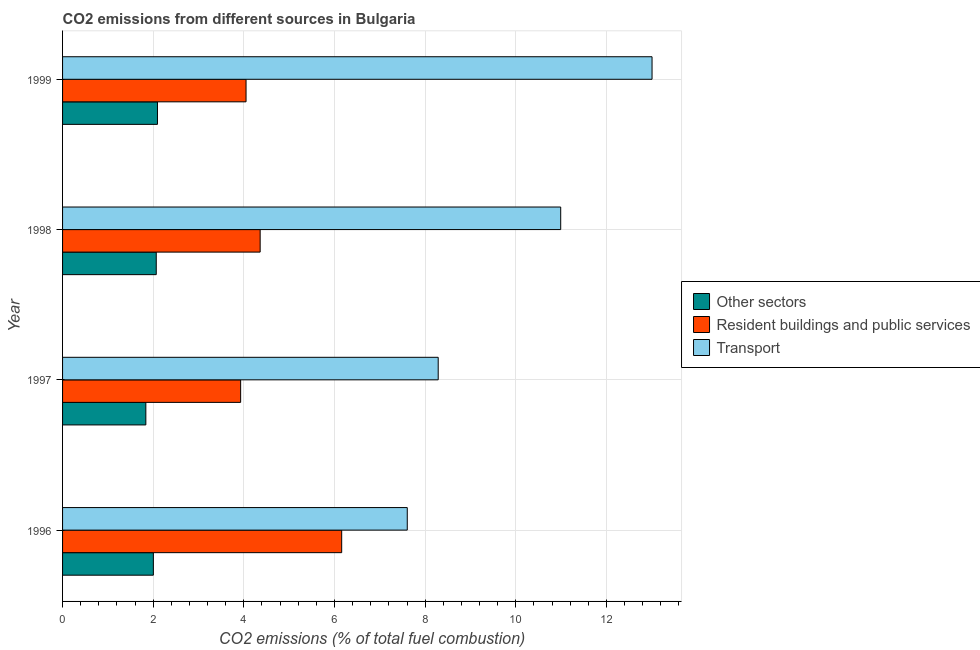How many different coloured bars are there?
Your response must be concise. 3. How many groups of bars are there?
Your answer should be compact. 4. How many bars are there on the 1st tick from the bottom?
Offer a very short reply. 3. In how many cases, is the number of bars for a given year not equal to the number of legend labels?
Offer a terse response. 0. What is the percentage of co2 emissions from transport in 1999?
Keep it short and to the point. 13.01. Across all years, what is the maximum percentage of co2 emissions from transport?
Offer a terse response. 13.01. Across all years, what is the minimum percentage of co2 emissions from resident buildings and public services?
Give a very brief answer. 3.93. In which year was the percentage of co2 emissions from resident buildings and public services maximum?
Your answer should be compact. 1996. What is the total percentage of co2 emissions from resident buildings and public services in the graph?
Your answer should be very brief. 18.5. What is the difference between the percentage of co2 emissions from other sectors in 1996 and that in 1999?
Provide a succinct answer. -0.09. What is the difference between the percentage of co2 emissions from other sectors in 1997 and the percentage of co2 emissions from transport in 1998?
Provide a short and direct response. -9.15. What is the average percentage of co2 emissions from transport per year?
Make the answer very short. 9.97. In the year 1999, what is the difference between the percentage of co2 emissions from other sectors and percentage of co2 emissions from transport?
Provide a short and direct response. -10.91. What is the ratio of the percentage of co2 emissions from resident buildings and public services in 1997 to that in 1998?
Give a very brief answer. 0.9. Is the difference between the percentage of co2 emissions from resident buildings and public services in 1996 and 1997 greater than the difference between the percentage of co2 emissions from other sectors in 1996 and 1997?
Provide a short and direct response. Yes. What is the difference between the highest and the second highest percentage of co2 emissions from transport?
Keep it short and to the point. 2.02. What is the difference between the highest and the lowest percentage of co2 emissions from other sectors?
Your answer should be compact. 0.26. What does the 3rd bar from the top in 1997 represents?
Your response must be concise. Other sectors. What does the 3rd bar from the bottom in 1997 represents?
Offer a very short reply. Transport. Is it the case that in every year, the sum of the percentage of co2 emissions from other sectors and percentage of co2 emissions from resident buildings and public services is greater than the percentage of co2 emissions from transport?
Provide a succinct answer. No. How many bars are there?
Your answer should be very brief. 12. Are all the bars in the graph horizontal?
Your answer should be very brief. Yes. How many years are there in the graph?
Keep it short and to the point. 4. What is the difference between two consecutive major ticks on the X-axis?
Offer a terse response. 2. Does the graph contain grids?
Your answer should be very brief. Yes. What is the title of the graph?
Provide a succinct answer. CO2 emissions from different sources in Bulgaria. What is the label or title of the X-axis?
Provide a succinct answer. CO2 emissions (% of total fuel combustion). What is the CO2 emissions (% of total fuel combustion) of Other sectors in 1996?
Make the answer very short. 2. What is the CO2 emissions (% of total fuel combustion) in Resident buildings and public services in 1996?
Your answer should be very brief. 6.16. What is the CO2 emissions (% of total fuel combustion) in Transport in 1996?
Give a very brief answer. 7.61. What is the CO2 emissions (% of total fuel combustion) in Other sectors in 1997?
Your response must be concise. 1.84. What is the CO2 emissions (% of total fuel combustion) in Resident buildings and public services in 1997?
Make the answer very short. 3.93. What is the CO2 emissions (% of total fuel combustion) of Transport in 1997?
Keep it short and to the point. 8.29. What is the CO2 emissions (% of total fuel combustion) of Other sectors in 1998?
Provide a short and direct response. 2.07. What is the CO2 emissions (% of total fuel combustion) of Resident buildings and public services in 1998?
Provide a succinct answer. 4.36. What is the CO2 emissions (% of total fuel combustion) in Transport in 1998?
Your response must be concise. 10.99. What is the CO2 emissions (% of total fuel combustion) of Other sectors in 1999?
Your answer should be compact. 2.09. What is the CO2 emissions (% of total fuel combustion) of Resident buildings and public services in 1999?
Keep it short and to the point. 4.05. What is the CO2 emissions (% of total fuel combustion) in Transport in 1999?
Provide a short and direct response. 13.01. Across all years, what is the maximum CO2 emissions (% of total fuel combustion) of Other sectors?
Make the answer very short. 2.09. Across all years, what is the maximum CO2 emissions (% of total fuel combustion) of Resident buildings and public services?
Keep it short and to the point. 6.16. Across all years, what is the maximum CO2 emissions (% of total fuel combustion) in Transport?
Offer a terse response. 13.01. Across all years, what is the minimum CO2 emissions (% of total fuel combustion) of Other sectors?
Your answer should be compact. 1.84. Across all years, what is the minimum CO2 emissions (% of total fuel combustion) of Resident buildings and public services?
Your answer should be very brief. 3.93. Across all years, what is the minimum CO2 emissions (% of total fuel combustion) of Transport?
Provide a short and direct response. 7.61. What is the total CO2 emissions (% of total fuel combustion) in Other sectors in the graph?
Make the answer very short. 8. What is the total CO2 emissions (% of total fuel combustion) in Resident buildings and public services in the graph?
Provide a succinct answer. 18.5. What is the total CO2 emissions (% of total fuel combustion) in Transport in the graph?
Offer a terse response. 39.89. What is the difference between the CO2 emissions (% of total fuel combustion) of Other sectors in 1996 and that in 1997?
Offer a very short reply. 0.17. What is the difference between the CO2 emissions (% of total fuel combustion) in Resident buildings and public services in 1996 and that in 1997?
Your answer should be compact. 2.23. What is the difference between the CO2 emissions (% of total fuel combustion) in Transport in 1996 and that in 1997?
Your answer should be compact. -0.68. What is the difference between the CO2 emissions (% of total fuel combustion) in Other sectors in 1996 and that in 1998?
Your response must be concise. -0.06. What is the difference between the CO2 emissions (% of total fuel combustion) of Resident buildings and public services in 1996 and that in 1998?
Keep it short and to the point. 1.8. What is the difference between the CO2 emissions (% of total fuel combustion) in Transport in 1996 and that in 1998?
Give a very brief answer. -3.39. What is the difference between the CO2 emissions (% of total fuel combustion) of Other sectors in 1996 and that in 1999?
Provide a short and direct response. -0.09. What is the difference between the CO2 emissions (% of total fuel combustion) in Resident buildings and public services in 1996 and that in 1999?
Your answer should be very brief. 2.11. What is the difference between the CO2 emissions (% of total fuel combustion) of Transport in 1996 and that in 1999?
Your answer should be compact. -5.4. What is the difference between the CO2 emissions (% of total fuel combustion) of Other sectors in 1997 and that in 1998?
Ensure brevity in your answer.  -0.23. What is the difference between the CO2 emissions (% of total fuel combustion) of Resident buildings and public services in 1997 and that in 1998?
Provide a short and direct response. -0.43. What is the difference between the CO2 emissions (% of total fuel combustion) of Transport in 1997 and that in 1998?
Give a very brief answer. -2.7. What is the difference between the CO2 emissions (% of total fuel combustion) of Other sectors in 1997 and that in 1999?
Your answer should be compact. -0.26. What is the difference between the CO2 emissions (% of total fuel combustion) of Resident buildings and public services in 1997 and that in 1999?
Give a very brief answer. -0.12. What is the difference between the CO2 emissions (% of total fuel combustion) of Transport in 1997 and that in 1999?
Ensure brevity in your answer.  -4.72. What is the difference between the CO2 emissions (% of total fuel combustion) of Other sectors in 1998 and that in 1999?
Offer a terse response. -0.03. What is the difference between the CO2 emissions (% of total fuel combustion) of Resident buildings and public services in 1998 and that in 1999?
Give a very brief answer. 0.31. What is the difference between the CO2 emissions (% of total fuel combustion) of Transport in 1998 and that in 1999?
Give a very brief answer. -2.02. What is the difference between the CO2 emissions (% of total fuel combustion) of Other sectors in 1996 and the CO2 emissions (% of total fuel combustion) of Resident buildings and public services in 1997?
Offer a terse response. -1.93. What is the difference between the CO2 emissions (% of total fuel combustion) of Other sectors in 1996 and the CO2 emissions (% of total fuel combustion) of Transport in 1997?
Your answer should be compact. -6.28. What is the difference between the CO2 emissions (% of total fuel combustion) of Resident buildings and public services in 1996 and the CO2 emissions (% of total fuel combustion) of Transport in 1997?
Give a very brief answer. -2.13. What is the difference between the CO2 emissions (% of total fuel combustion) in Other sectors in 1996 and the CO2 emissions (% of total fuel combustion) in Resident buildings and public services in 1998?
Provide a succinct answer. -2.36. What is the difference between the CO2 emissions (% of total fuel combustion) of Other sectors in 1996 and the CO2 emissions (% of total fuel combustion) of Transport in 1998?
Your answer should be very brief. -8.99. What is the difference between the CO2 emissions (% of total fuel combustion) of Resident buildings and public services in 1996 and the CO2 emissions (% of total fuel combustion) of Transport in 1998?
Ensure brevity in your answer.  -4.83. What is the difference between the CO2 emissions (% of total fuel combustion) of Other sectors in 1996 and the CO2 emissions (% of total fuel combustion) of Resident buildings and public services in 1999?
Provide a short and direct response. -2.05. What is the difference between the CO2 emissions (% of total fuel combustion) in Other sectors in 1996 and the CO2 emissions (% of total fuel combustion) in Transport in 1999?
Offer a terse response. -11. What is the difference between the CO2 emissions (% of total fuel combustion) in Resident buildings and public services in 1996 and the CO2 emissions (% of total fuel combustion) in Transport in 1999?
Your answer should be very brief. -6.85. What is the difference between the CO2 emissions (% of total fuel combustion) in Other sectors in 1997 and the CO2 emissions (% of total fuel combustion) in Resident buildings and public services in 1998?
Give a very brief answer. -2.52. What is the difference between the CO2 emissions (% of total fuel combustion) of Other sectors in 1997 and the CO2 emissions (% of total fuel combustion) of Transport in 1998?
Ensure brevity in your answer.  -9.15. What is the difference between the CO2 emissions (% of total fuel combustion) in Resident buildings and public services in 1997 and the CO2 emissions (% of total fuel combustion) in Transport in 1998?
Your answer should be very brief. -7.06. What is the difference between the CO2 emissions (% of total fuel combustion) in Other sectors in 1997 and the CO2 emissions (% of total fuel combustion) in Resident buildings and public services in 1999?
Your response must be concise. -2.21. What is the difference between the CO2 emissions (% of total fuel combustion) in Other sectors in 1997 and the CO2 emissions (% of total fuel combustion) in Transport in 1999?
Offer a terse response. -11.17. What is the difference between the CO2 emissions (% of total fuel combustion) in Resident buildings and public services in 1997 and the CO2 emissions (% of total fuel combustion) in Transport in 1999?
Ensure brevity in your answer.  -9.08. What is the difference between the CO2 emissions (% of total fuel combustion) in Other sectors in 1998 and the CO2 emissions (% of total fuel combustion) in Resident buildings and public services in 1999?
Provide a short and direct response. -1.98. What is the difference between the CO2 emissions (% of total fuel combustion) of Other sectors in 1998 and the CO2 emissions (% of total fuel combustion) of Transport in 1999?
Your answer should be very brief. -10.94. What is the difference between the CO2 emissions (% of total fuel combustion) of Resident buildings and public services in 1998 and the CO2 emissions (% of total fuel combustion) of Transport in 1999?
Provide a succinct answer. -8.65. What is the average CO2 emissions (% of total fuel combustion) of Other sectors per year?
Give a very brief answer. 2. What is the average CO2 emissions (% of total fuel combustion) in Resident buildings and public services per year?
Provide a succinct answer. 4.62. What is the average CO2 emissions (% of total fuel combustion) in Transport per year?
Make the answer very short. 9.97. In the year 1996, what is the difference between the CO2 emissions (% of total fuel combustion) of Other sectors and CO2 emissions (% of total fuel combustion) of Resident buildings and public services?
Give a very brief answer. -4.16. In the year 1996, what is the difference between the CO2 emissions (% of total fuel combustion) of Other sectors and CO2 emissions (% of total fuel combustion) of Transport?
Offer a very short reply. -5.6. In the year 1996, what is the difference between the CO2 emissions (% of total fuel combustion) in Resident buildings and public services and CO2 emissions (% of total fuel combustion) in Transport?
Give a very brief answer. -1.45. In the year 1997, what is the difference between the CO2 emissions (% of total fuel combustion) of Other sectors and CO2 emissions (% of total fuel combustion) of Resident buildings and public services?
Ensure brevity in your answer.  -2.09. In the year 1997, what is the difference between the CO2 emissions (% of total fuel combustion) in Other sectors and CO2 emissions (% of total fuel combustion) in Transport?
Make the answer very short. -6.45. In the year 1997, what is the difference between the CO2 emissions (% of total fuel combustion) of Resident buildings and public services and CO2 emissions (% of total fuel combustion) of Transport?
Give a very brief answer. -4.36. In the year 1998, what is the difference between the CO2 emissions (% of total fuel combustion) of Other sectors and CO2 emissions (% of total fuel combustion) of Resident buildings and public services?
Your answer should be compact. -2.29. In the year 1998, what is the difference between the CO2 emissions (% of total fuel combustion) of Other sectors and CO2 emissions (% of total fuel combustion) of Transport?
Your answer should be very brief. -8.92. In the year 1998, what is the difference between the CO2 emissions (% of total fuel combustion) of Resident buildings and public services and CO2 emissions (% of total fuel combustion) of Transport?
Your answer should be very brief. -6.63. In the year 1999, what is the difference between the CO2 emissions (% of total fuel combustion) in Other sectors and CO2 emissions (% of total fuel combustion) in Resident buildings and public services?
Your answer should be compact. -1.95. In the year 1999, what is the difference between the CO2 emissions (% of total fuel combustion) in Other sectors and CO2 emissions (% of total fuel combustion) in Transport?
Your answer should be compact. -10.91. In the year 1999, what is the difference between the CO2 emissions (% of total fuel combustion) in Resident buildings and public services and CO2 emissions (% of total fuel combustion) in Transport?
Give a very brief answer. -8.96. What is the ratio of the CO2 emissions (% of total fuel combustion) of Other sectors in 1996 to that in 1997?
Your response must be concise. 1.09. What is the ratio of the CO2 emissions (% of total fuel combustion) of Resident buildings and public services in 1996 to that in 1997?
Give a very brief answer. 1.57. What is the ratio of the CO2 emissions (% of total fuel combustion) of Transport in 1996 to that in 1997?
Your answer should be very brief. 0.92. What is the ratio of the CO2 emissions (% of total fuel combustion) of Other sectors in 1996 to that in 1998?
Ensure brevity in your answer.  0.97. What is the ratio of the CO2 emissions (% of total fuel combustion) of Resident buildings and public services in 1996 to that in 1998?
Give a very brief answer. 1.41. What is the ratio of the CO2 emissions (% of total fuel combustion) in Transport in 1996 to that in 1998?
Your answer should be compact. 0.69. What is the ratio of the CO2 emissions (% of total fuel combustion) in Other sectors in 1996 to that in 1999?
Offer a terse response. 0.96. What is the ratio of the CO2 emissions (% of total fuel combustion) of Resident buildings and public services in 1996 to that in 1999?
Your answer should be compact. 1.52. What is the ratio of the CO2 emissions (% of total fuel combustion) of Transport in 1996 to that in 1999?
Offer a terse response. 0.58. What is the ratio of the CO2 emissions (% of total fuel combustion) of Resident buildings and public services in 1997 to that in 1998?
Give a very brief answer. 0.9. What is the ratio of the CO2 emissions (% of total fuel combustion) of Transport in 1997 to that in 1998?
Ensure brevity in your answer.  0.75. What is the ratio of the CO2 emissions (% of total fuel combustion) in Other sectors in 1997 to that in 1999?
Ensure brevity in your answer.  0.88. What is the ratio of the CO2 emissions (% of total fuel combustion) of Resident buildings and public services in 1997 to that in 1999?
Ensure brevity in your answer.  0.97. What is the ratio of the CO2 emissions (% of total fuel combustion) of Transport in 1997 to that in 1999?
Give a very brief answer. 0.64. What is the ratio of the CO2 emissions (% of total fuel combustion) in Other sectors in 1998 to that in 1999?
Offer a very short reply. 0.99. What is the ratio of the CO2 emissions (% of total fuel combustion) of Resident buildings and public services in 1998 to that in 1999?
Your response must be concise. 1.08. What is the ratio of the CO2 emissions (% of total fuel combustion) in Transport in 1998 to that in 1999?
Ensure brevity in your answer.  0.84. What is the difference between the highest and the second highest CO2 emissions (% of total fuel combustion) of Other sectors?
Give a very brief answer. 0.03. What is the difference between the highest and the second highest CO2 emissions (% of total fuel combustion) in Resident buildings and public services?
Your answer should be very brief. 1.8. What is the difference between the highest and the second highest CO2 emissions (% of total fuel combustion) of Transport?
Offer a terse response. 2.02. What is the difference between the highest and the lowest CO2 emissions (% of total fuel combustion) of Other sectors?
Your answer should be very brief. 0.26. What is the difference between the highest and the lowest CO2 emissions (% of total fuel combustion) of Resident buildings and public services?
Give a very brief answer. 2.23. What is the difference between the highest and the lowest CO2 emissions (% of total fuel combustion) in Transport?
Make the answer very short. 5.4. 